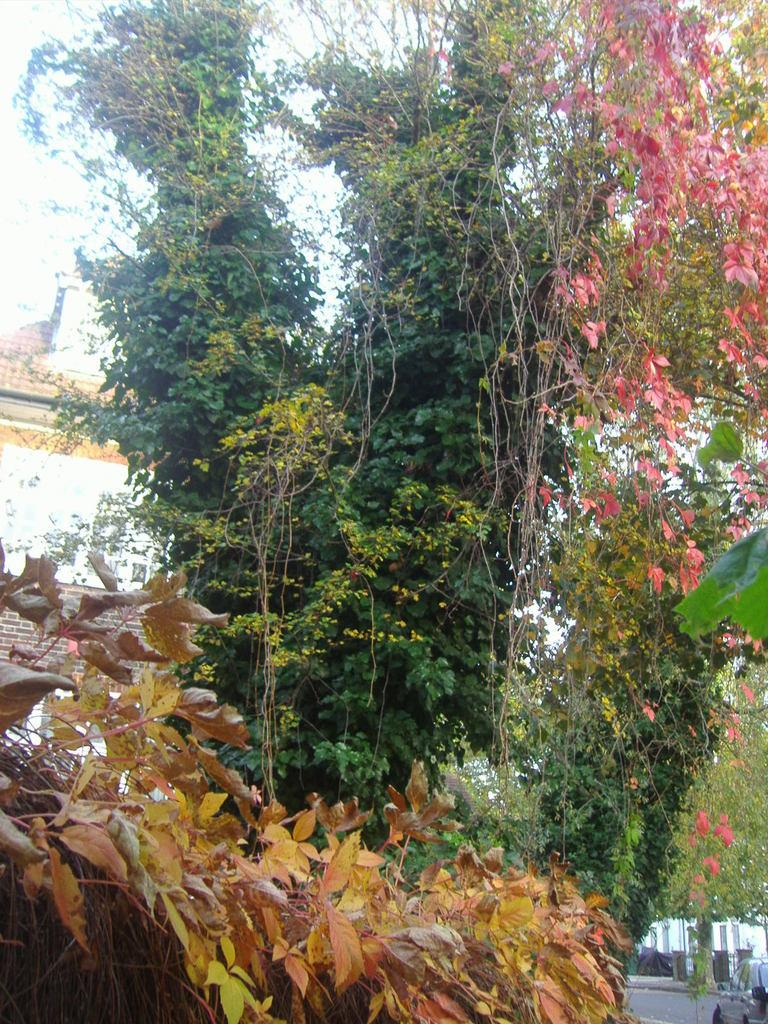Where was the picture taken? The picture was clicked outside. What can be seen in the foreground of the image? There are dry leaves and trees in the foreground. What is visible in the background of the image? There is a sky, a building, a vehicle, and other objects in the background. What type of stitch is being used to sew the dry leaves together in the image? There is no stitching or sewing of dry leaves in the image; they are simply scattered in the foreground. 